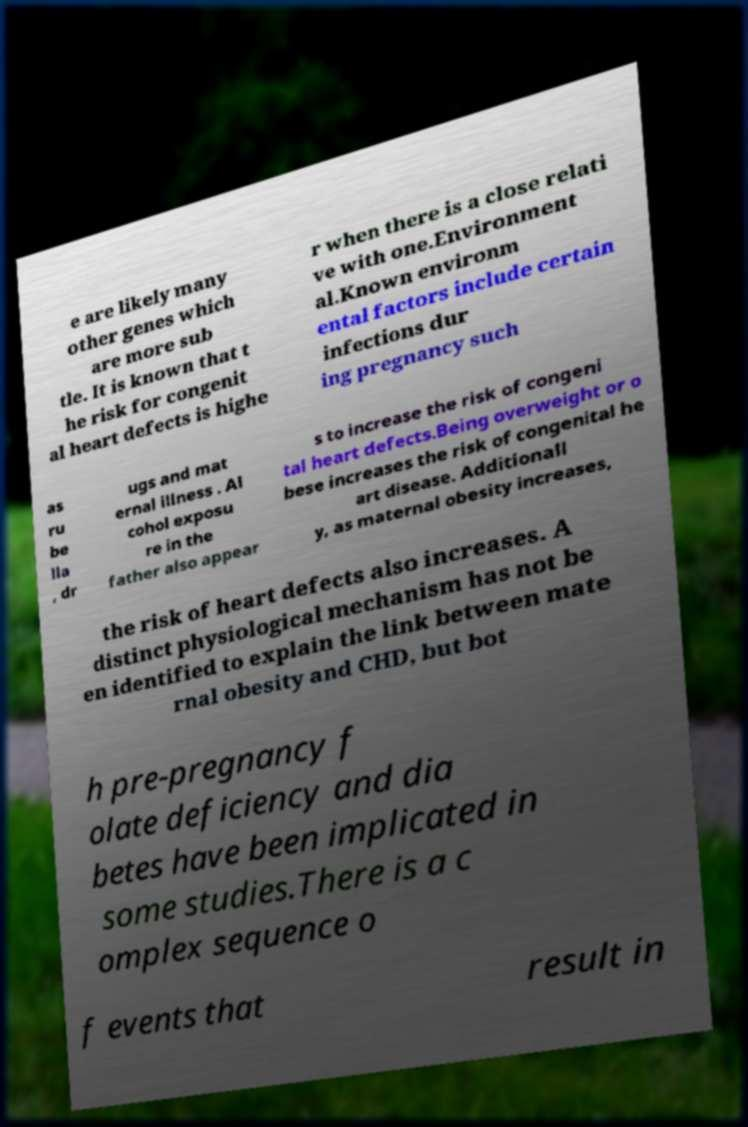Please identify and transcribe the text found in this image. e are likely many other genes which are more sub tle. It is known that t he risk for congenit al heart defects is highe r when there is a close relati ve with one.Environment al.Known environm ental factors include certain infections dur ing pregnancy such as ru be lla , dr ugs and mat ernal illness . Al cohol exposu re in the father also appear s to increase the risk of congeni tal heart defects.Being overweight or o bese increases the risk of congenital he art disease. Additionall y, as maternal obesity increases, the risk of heart defects also increases. A distinct physiological mechanism has not be en identified to explain the link between mate rnal obesity and CHD, but bot h pre-pregnancy f olate deficiency and dia betes have been implicated in some studies.There is a c omplex sequence o f events that result in 